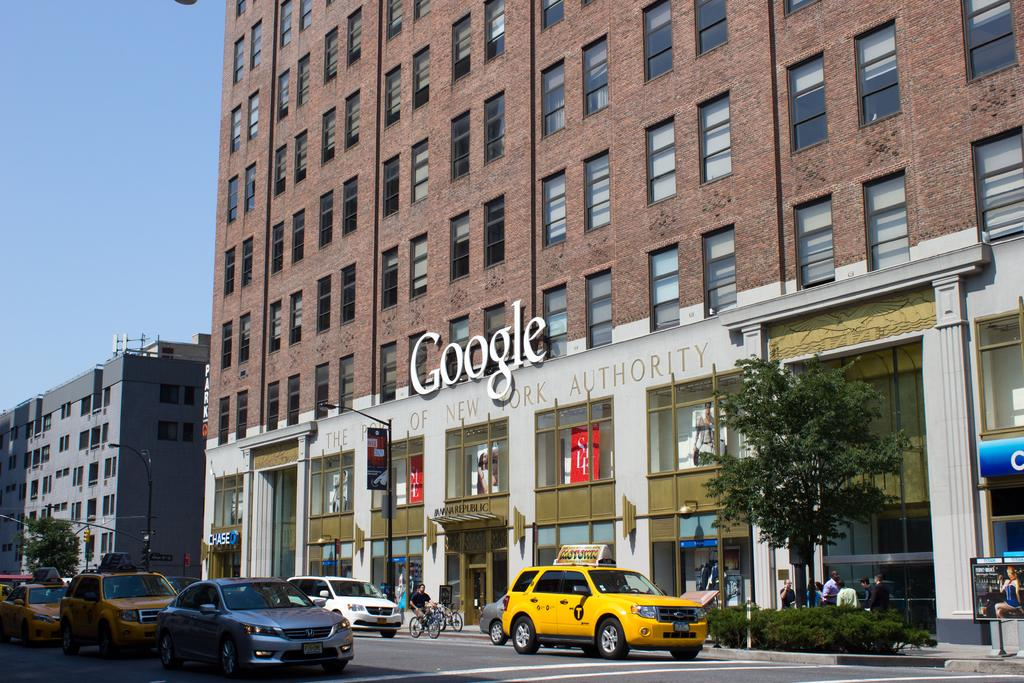What type of structures can be seen in the image? There are buildings in the image. What objects are present in the image that might be used for displaying information or advertisements? There are boards in the image. What can be seen that provides illumination in the image? There are lights in the image. What type of natural elements are visible in the image? There are trees in the image. What type of vertical structures can be seen in the image? There are poles in the image. What type of living organisms are visible in the image besides humans? There are plants in the image. What type of living organisms can be seen moving around in the image? There are people in the image. What type of transportation is visible on the road in the image? There are vehicles on the road in the image. What part of the natural environment is visible in the image? The sky is visible in the top left corner of the image. What type of hobby is the doll participating in while holding a can in the image? There is no doll or can present in the image; it features buildings, boards, lights, trees, poles, plants, people, vehicles, and the sky. 